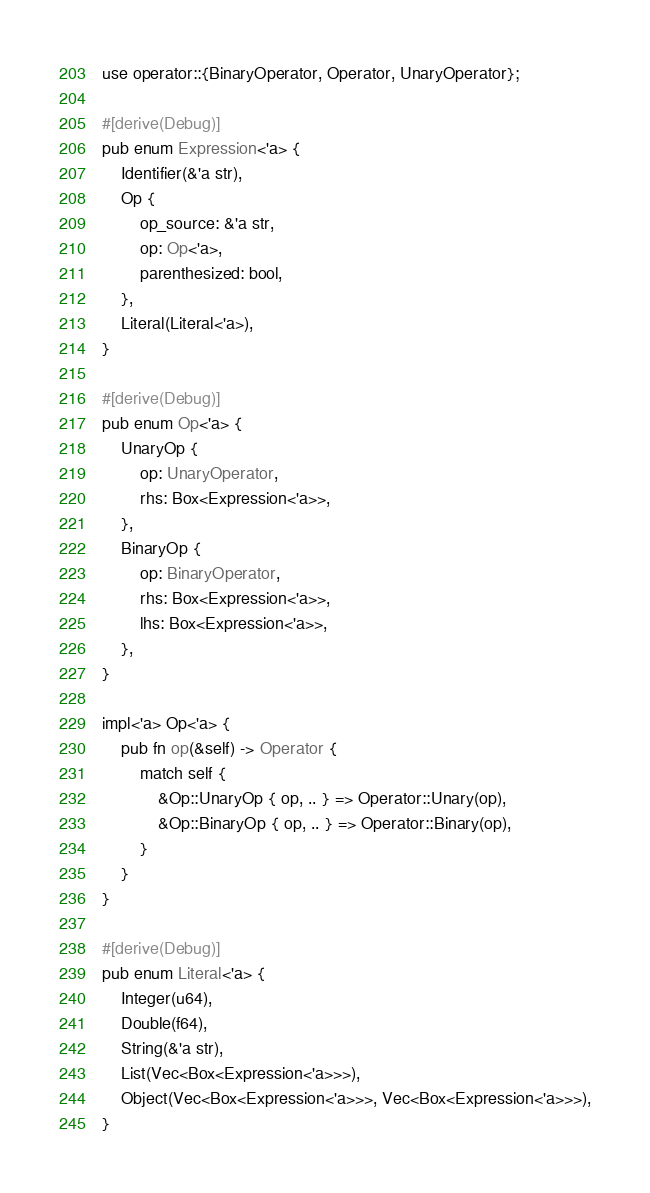Convert code to text. <code><loc_0><loc_0><loc_500><loc_500><_Rust_>use operator::{BinaryOperator, Operator, UnaryOperator};

#[derive(Debug)]
pub enum Expression<'a> {
    Identifier(&'a str),
    Op {
        op_source: &'a str,
        op: Op<'a>,
        parenthesized: bool,
    },
    Literal(Literal<'a>),
}

#[derive(Debug)]
pub enum Op<'a> {
    UnaryOp {
        op: UnaryOperator,
        rhs: Box<Expression<'a>>,
    },
    BinaryOp {
        op: BinaryOperator,
        rhs: Box<Expression<'a>>,
        lhs: Box<Expression<'a>>,
    },
}

impl<'a> Op<'a> {
    pub fn op(&self) -> Operator {
        match self {
            &Op::UnaryOp { op, .. } => Operator::Unary(op),
            &Op::BinaryOp { op, .. } => Operator::Binary(op),
        }
    }
}

#[derive(Debug)]
pub enum Literal<'a> {
    Integer(u64),
    Double(f64),
    String(&'a str),
    List(Vec<Box<Expression<'a>>>),
    Object(Vec<Box<Expression<'a>>>, Vec<Box<Expression<'a>>>),
}
</code> 